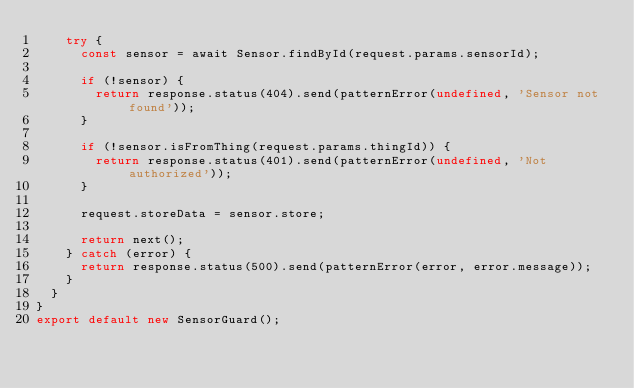Convert code to text. <code><loc_0><loc_0><loc_500><loc_500><_TypeScript_>    try {
      const sensor = await Sensor.findById(request.params.sensorId);

      if (!sensor) {
        return response.status(404).send(patternError(undefined, 'Sensor not found'));
      }

      if (!sensor.isFromThing(request.params.thingId)) {
        return response.status(401).send(patternError(undefined, 'Not authorized'));
      }

      request.storeData = sensor.store;

      return next();
    } catch (error) {
      return response.status(500).send(patternError(error, error.message));
    }
  }
}
export default new SensorGuard();
</code> 